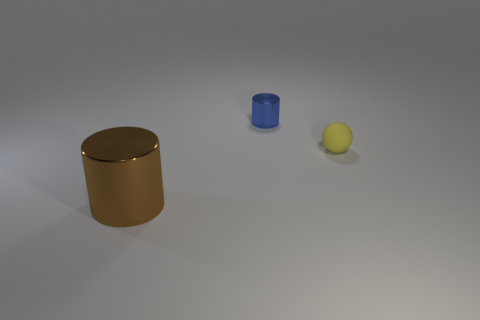Subtract all spheres. How many objects are left? 2 Add 1 brown shiny cylinders. How many objects exist? 4 Add 1 metallic things. How many metallic things exist? 3 Subtract all brown cylinders. How many cylinders are left? 1 Subtract 0 red spheres. How many objects are left? 3 Subtract 2 cylinders. How many cylinders are left? 0 Subtract all purple cylinders. Subtract all purple spheres. How many cylinders are left? 2 Subtract all red spheres. How many gray cylinders are left? 0 Subtract all small cyan metal objects. Subtract all yellow objects. How many objects are left? 2 Add 2 rubber balls. How many rubber balls are left? 3 